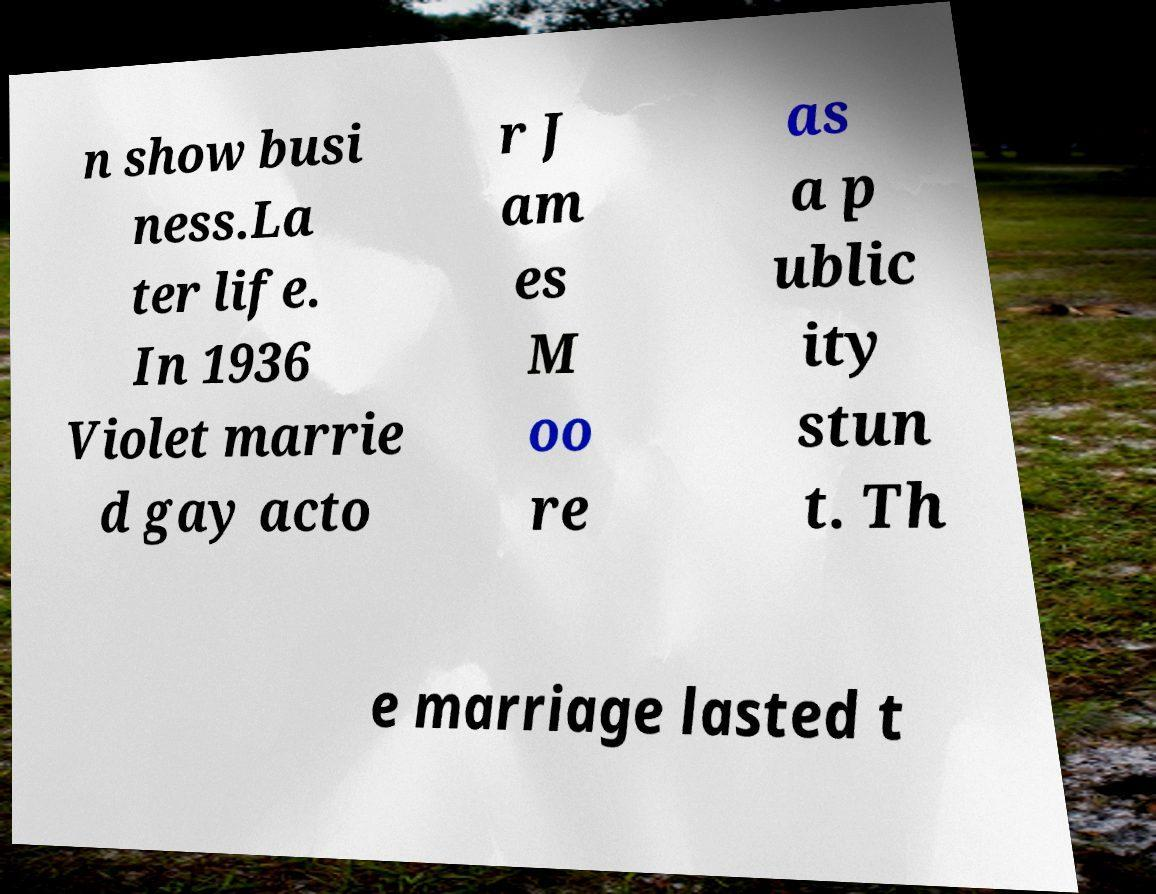Could you assist in decoding the text presented in this image and type it out clearly? n show busi ness.La ter life. In 1936 Violet marrie d gay acto r J am es M oo re as a p ublic ity stun t. Th e marriage lasted t 